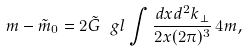<formula> <loc_0><loc_0><loc_500><loc_500>m - \tilde { m } _ { 0 } = 2 \tilde { G } \ g l \int \frac { d x d ^ { 2 } k _ { \perp } } { 2 x ( 2 \pi ) ^ { 3 } } \, 4 m ,</formula> 